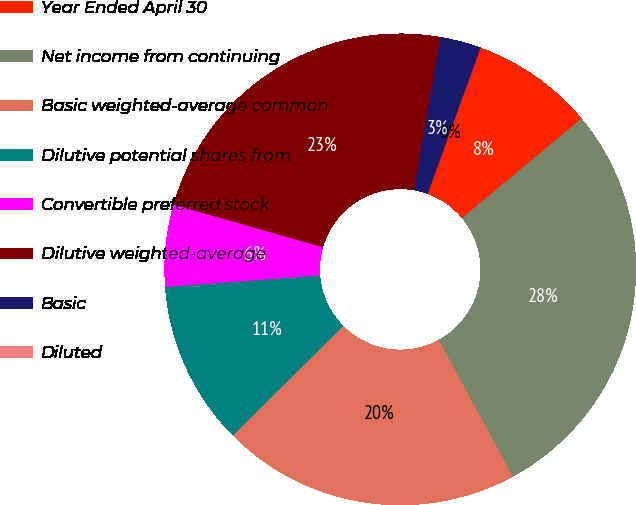<chart> <loc_0><loc_0><loc_500><loc_500><pie_chart><fcel>Year Ended April 30<fcel>Net income from continuing<fcel>Basic weighted-average common<fcel>Dilutive potential shares from<fcel>Convertible preferred stock<fcel>Dilutive weighted-average<fcel>Basic<fcel>Diluted<nl><fcel>8.43%<fcel>28.12%<fcel>20.48%<fcel>11.25%<fcel>5.62%<fcel>23.29%<fcel>2.81%<fcel>0.0%<nl></chart> 